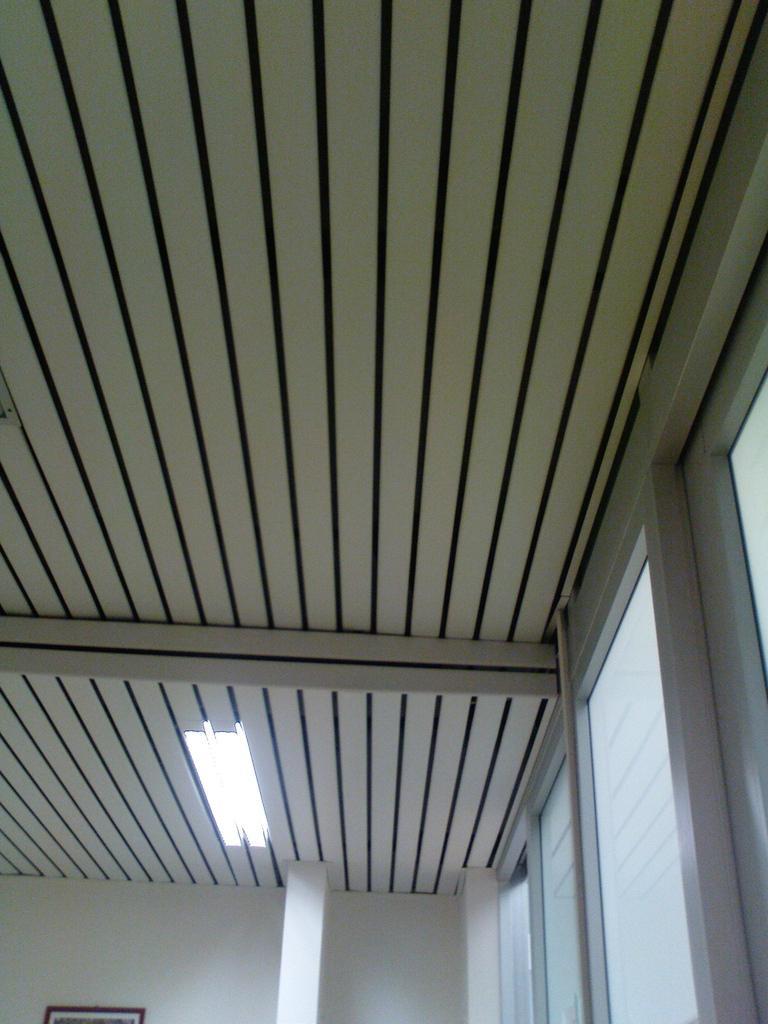In one or two sentences, can you explain what this image depicts? This image is clicked inside a room. On the right there are windows, glasses. At the top there are lights and roof. At the bottom there is a photo frame, pillar and wall. 